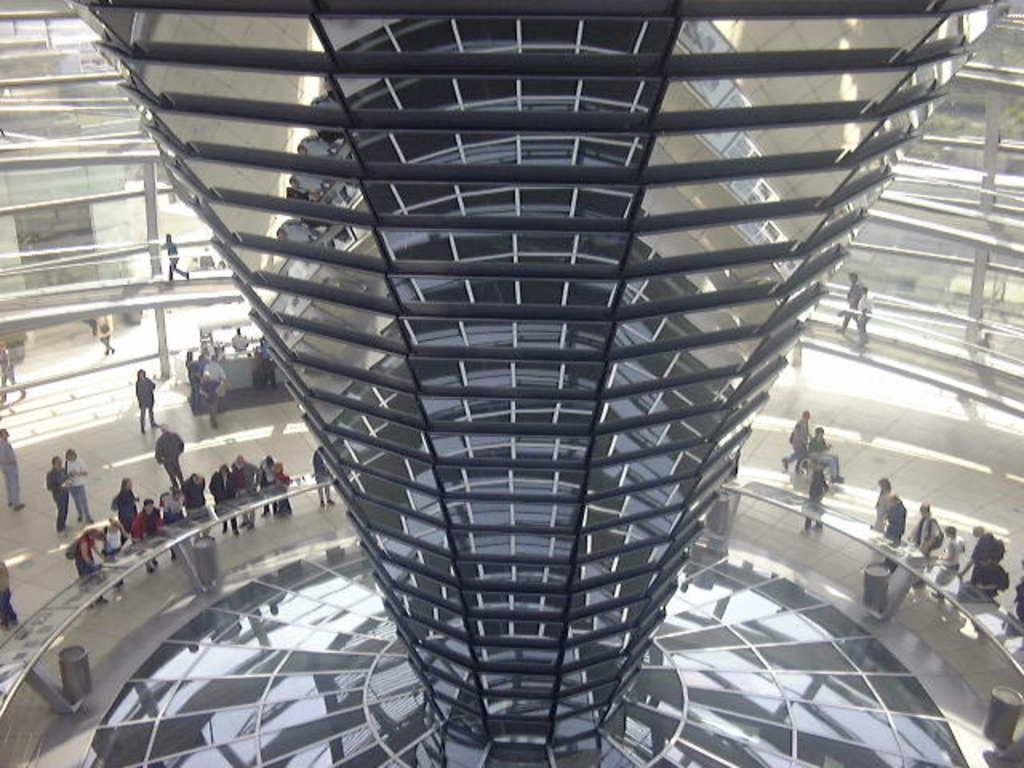Can you describe this image briefly? This picture describes about group of people, few people are standing and few people are walking, in the middle of the image we can see a tower. 